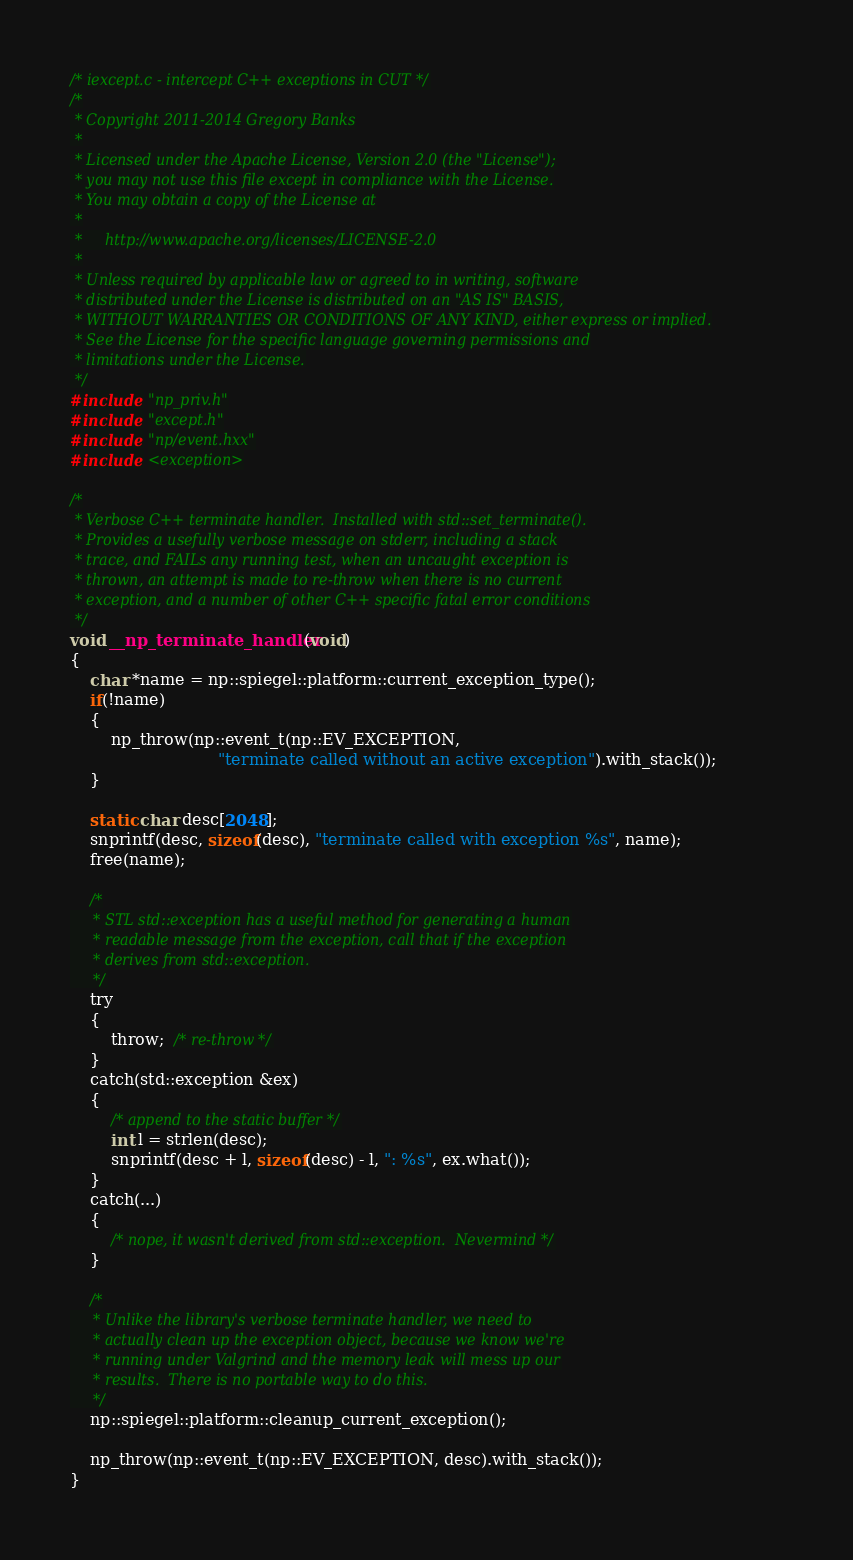<code> <loc_0><loc_0><loc_500><loc_500><_C_>/* iexcept.c - intercept C++ exceptions in CUT */
/*
 * Copyright 2011-2014 Gregory Banks
 *
 * Licensed under the Apache License, Version 2.0 (the "License");
 * you may not use this file except in compliance with the License.
 * You may obtain a copy of the License at
 *
 *     http://www.apache.org/licenses/LICENSE-2.0
 *
 * Unless required by applicable law or agreed to in writing, software
 * distributed under the License is distributed on an "AS IS" BASIS,
 * WITHOUT WARRANTIES OR CONDITIONS OF ANY KIND, either express or implied.
 * See the License for the specific language governing permissions and
 * limitations under the License.
 */
#include "np_priv.h"
#include "except.h"
#include "np/event.hxx"
#include <exception>

/*
 * Verbose C++ terminate handler.  Installed with std::set_terminate().
 * Provides a usefully verbose message on stderr, including a stack
 * trace, and FAILs any running test, when an uncaught exception is
 * thrown, an attempt is made to re-throw when there is no current
 * exception, and a number of other C++ specific fatal error conditions
 */
void __np_terminate_handler(void)
{
    char *name = np::spiegel::platform::current_exception_type();
    if(!name)
    {
        np_throw(np::event_t(np::EV_EXCEPTION,
                             "terminate called without an active exception").with_stack());
    }

    static char desc[2048];
    snprintf(desc, sizeof(desc), "terminate called with exception %s", name);
    free(name);

    /*
     * STL std::exception has a useful method for generating a human
     * readable message from the exception, call that if the exception
     * derives from std::exception.
     */
    try
    {
        throw;  /* re-throw */
    }
    catch(std::exception &ex)
    {
        /* append to the static buffer */
        int l = strlen(desc);
        snprintf(desc + l, sizeof(desc) - l, ": %s", ex.what());
    }
    catch(...)
    {
        /* nope, it wasn't derived from std::exception.  Nevermind */
    }

    /*
     * Unlike the library's verbose terminate handler, we need to
     * actually clean up the exception object, because we know we're
     * running under Valgrind and the memory leak will mess up our
     * results.  There is no portable way to do this.
     */
    np::spiegel::platform::cleanup_current_exception();

    np_throw(np::event_t(np::EV_EXCEPTION, desc).with_stack());
}
</code> 